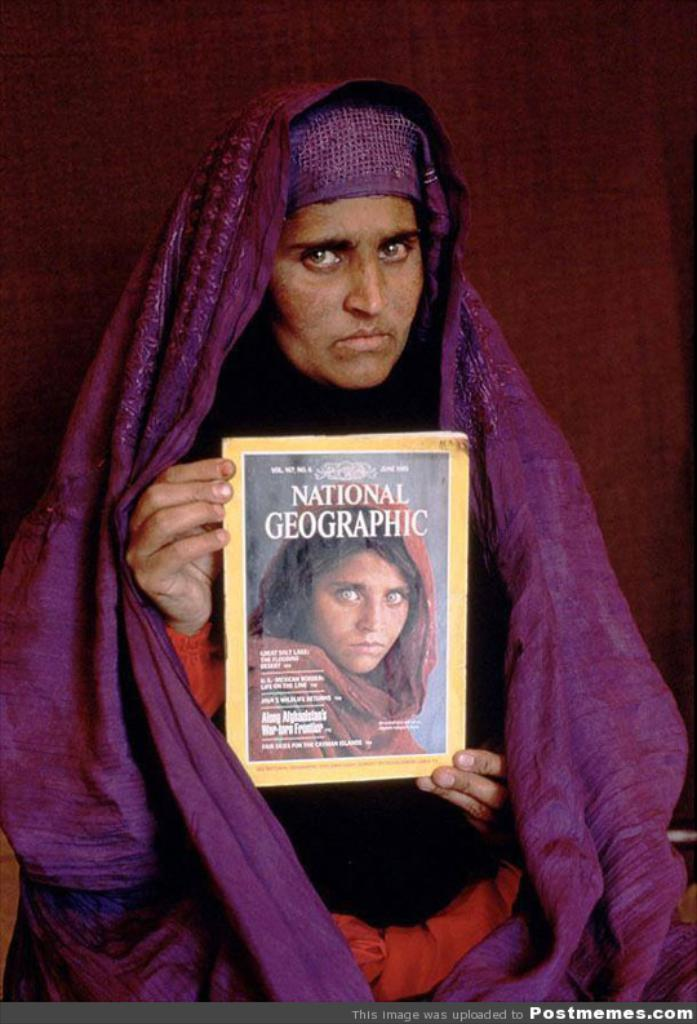What is the woman wearing in the image? The woman is wearing a black and red dress and a purple cloth around her. What is the woman holding in the image? The woman is holding a book in her hands. What is the color of the background in the image? The background color is brown. Can you see any fangs on the woman in the image? There are no fangs visible on the woman in the image. Is there a monkey present in the image? There is no monkey present in the image. 